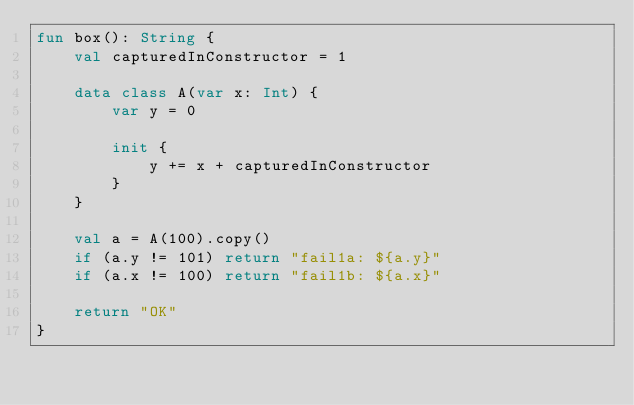Convert code to text. <code><loc_0><loc_0><loc_500><loc_500><_Kotlin_>fun box(): String {
    val capturedInConstructor = 1

    data class A(var x: Int) {
        var y = 0

        init {
            y += x + capturedInConstructor
        }
    }

    val a = A(100).copy()
    if (a.y != 101) return "fail1a: ${a.y}"
    if (a.x != 100) return "fail1b: ${a.x}"

    return "OK"
}</code> 